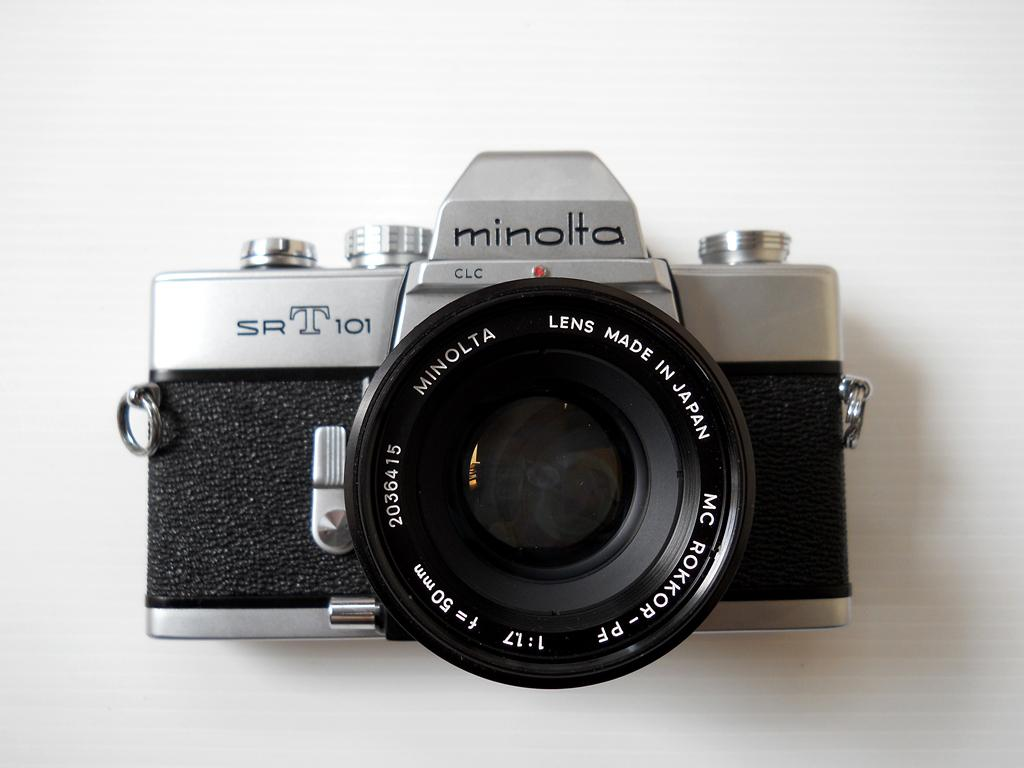<image>
Write a terse but informative summary of the picture. An older Minolta camera that is model SRT 101. 